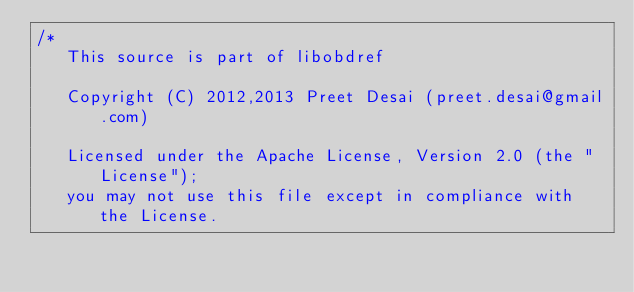<code> <loc_0><loc_0><loc_500><loc_500><_C++_>/*
   This source is part of libobdref

   Copyright (C) 2012,2013 Preet Desai (preet.desai@gmail.com)

   Licensed under the Apache License, Version 2.0 (the "License");
   you may not use this file except in compliance with the License.</code> 